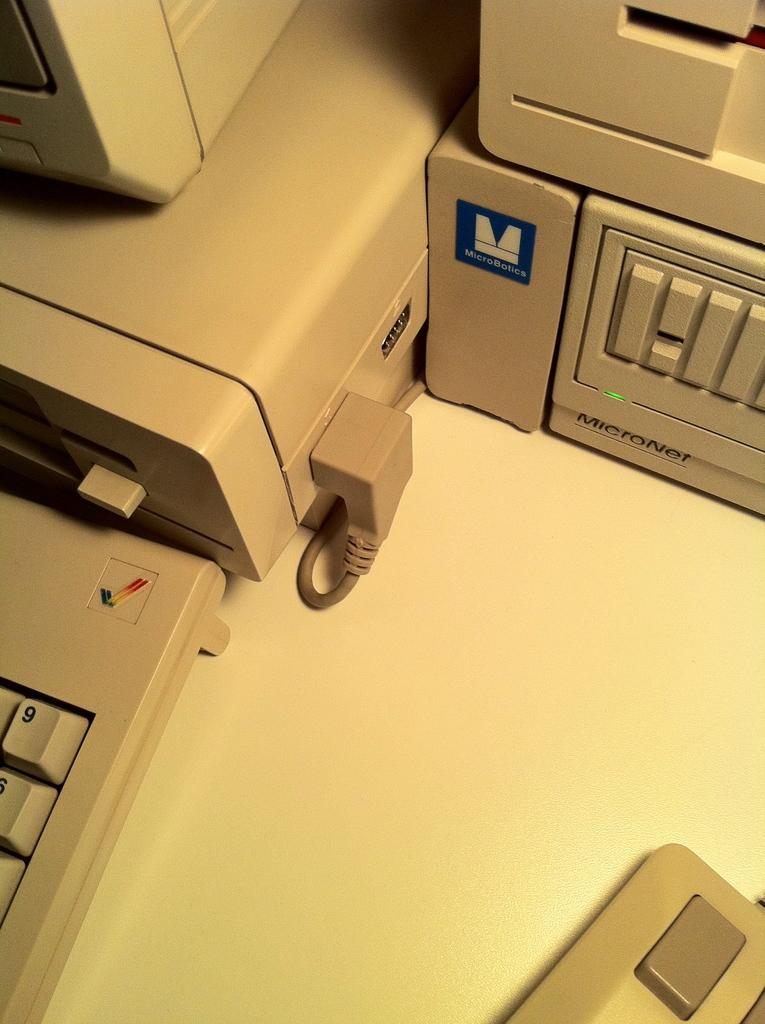Provide a one-sentence caption for the provided image. an old fashioned computer with the number nine visible on the keyboard. 